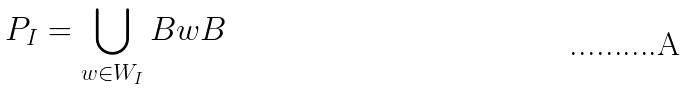Convert formula to latex. <formula><loc_0><loc_0><loc_500><loc_500>P _ { I } = \bigcup _ { w \in W _ { I } } B w B</formula> 